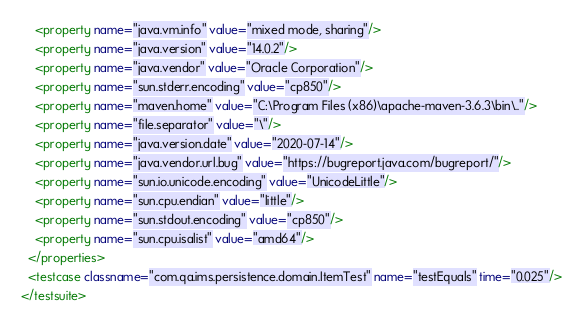Convert code to text. <code><loc_0><loc_0><loc_500><loc_500><_XML_>    <property name="java.vm.info" value="mixed mode, sharing"/>
    <property name="java.version" value="14.0.2"/>
    <property name="java.vendor" value="Oracle Corporation"/>
    <property name="sun.stderr.encoding" value="cp850"/>
    <property name="maven.home" value="C:\Program Files (x86)\apache-maven-3.6.3\bin\.."/>
    <property name="file.separator" value="\"/>
    <property name="java.version.date" value="2020-07-14"/>
    <property name="java.vendor.url.bug" value="https://bugreport.java.com/bugreport/"/>
    <property name="sun.io.unicode.encoding" value="UnicodeLittle"/>
    <property name="sun.cpu.endian" value="little"/>
    <property name="sun.stdout.encoding" value="cp850"/>
    <property name="sun.cpu.isalist" value="amd64"/>
  </properties>
  <testcase classname="com.qa.ims.persistence.domain.ItemTest" name="testEquals" time="0.025"/>
</testsuite></code> 